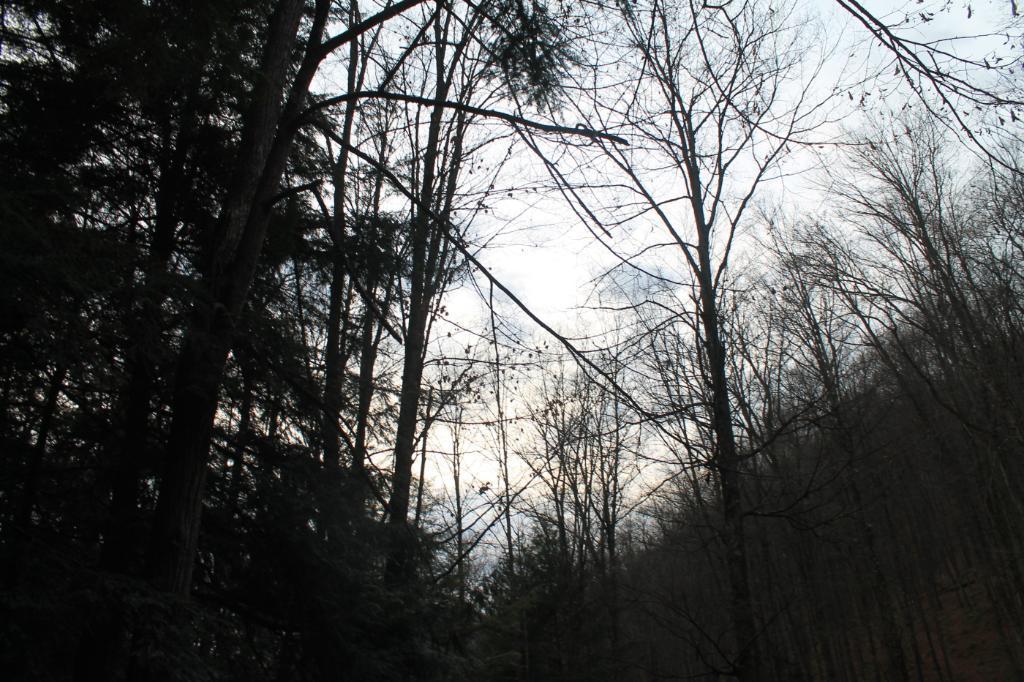How would you summarize this image in a sentence or two? In the image we can see some trees. Behind the trees there are some clouds and sky. 